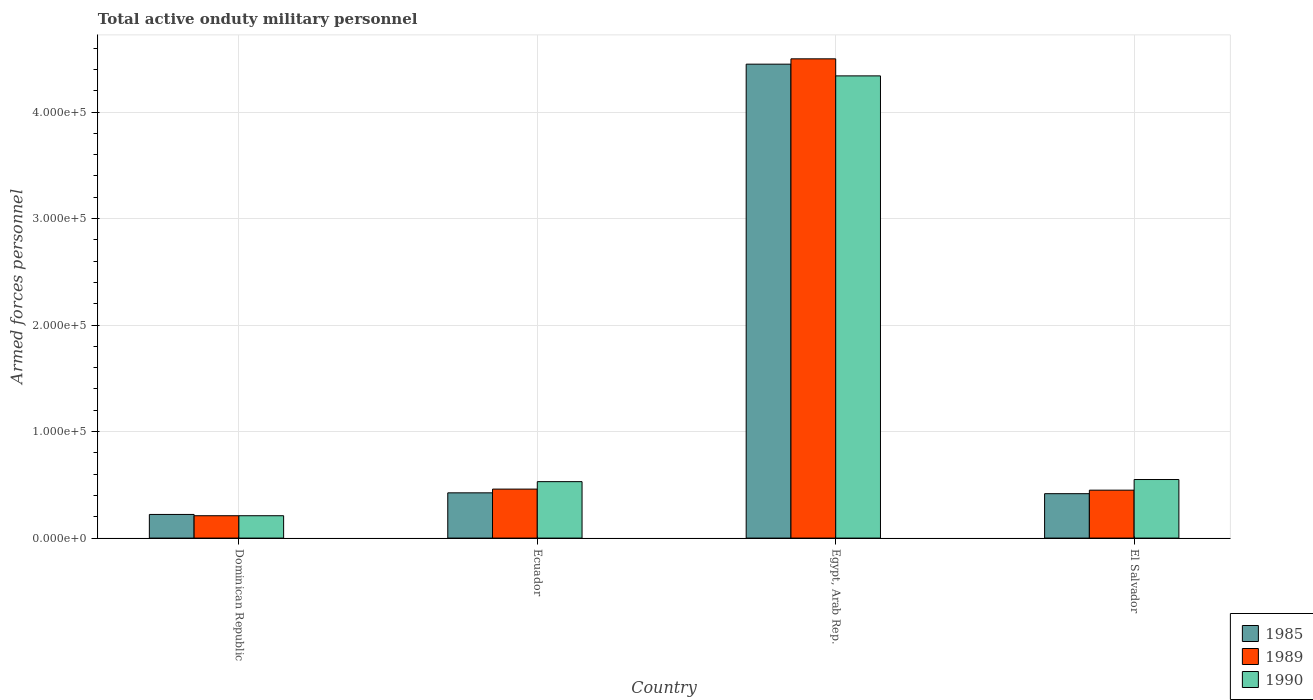How many different coloured bars are there?
Provide a succinct answer. 3. Are the number of bars per tick equal to the number of legend labels?
Provide a short and direct response. Yes. Are the number of bars on each tick of the X-axis equal?
Offer a terse response. Yes. How many bars are there on the 2nd tick from the left?
Your response must be concise. 3. How many bars are there on the 1st tick from the right?
Offer a terse response. 3. What is the label of the 1st group of bars from the left?
Your answer should be compact. Dominican Republic. What is the number of armed forces personnel in 1989 in Egypt, Arab Rep.?
Make the answer very short. 4.50e+05. Across all countries, what is the maximum number of armed forces personnel in 1990?
Give a very brief answer. 4.34e+05. Across all countries, what is the minimum number of armed forces personnel in 1990?
Your response must be concise. 2.10e+04. In which country was the number of armed forces personnel in 1985 maximum?
Offer a terse response. Egypt, Arab Rep. In which country was the number of armed forces personnel in 1989 minimum?
Offer a very short reply. Dominican Republic. What is the total number of armed forces personnel in 1989 in the graph?
Provide a succinct answer. 5.62e+05. What is the difference between the number of armed forces personnel in 1990 in Ecuador and that in Egypt, Arab Rep.?
Offer a terse response. -3.81e+05. What is the difference between the number of armed forces personnel in 1985 in Dominican Republic and the number of armed forces personnel in 1989 in Egypt, Arab Rep.?
Make the answer very short. -4.28e+05. What is the average number of armed forces personnel in 1989 per country?
Keep it short and to the point. 1.40e+05. What is the difference between the number of armed forces personnel of/in 1985 and number of armed forces personnel of/in 1989 in Dominican Republic?
Give a very brief answer. 1200. What is the ratio of the number of armed forces personnel in 1989 in Dominican Republic to that in Egypt, Arab Rep.?
Keep it short and to the point. 0.05. Is the difference between the number of armed forces personnel in 1985 in Ecuador and El Salvador greater than the difference between the number of armed forces personnel in 1989 in Ecuador and El Salvador?
Give a very brief answer. No. What is the difference between the highest and the second highest number of armed forces personnel in 1985?
Offer a terse response. 4.02e+05. What is the difference between the highest and the lowest number of armed forces personnel in 1989?
Keep it short and to the point. 4.29e+05. In how many countries, is the number of armed forces personnel in 1990 greater than the average number of armed forces personnel in 1990 taken over all countries?
Keep it short and to the point. 1. What does the 3rd bar from the left in El Salvador represents?
Provide a short and direct response. 1990. How many countries are there in the graph?
Provide a succinct answer. 4. Are the values on the major ticks of Y-axis written in scientific E-notation?
Provide a short and direct response. Yes. Where does the legend appear in the graph?
Provide a short and direct response. Bottom right. What is the title of the graph?
Provide a short and direct response. Total active onduty military personnel. What is the label or title of the Y-axis?
Your response must be concise. Armed forces personnel. What is the Armed forces personnel of 1985 in Dominican Republic?
Provide a succinct answer. 2.22e+04. What is the Armed forces personnel in 1989 in Dominican Republic?
Your answer should be compact. 2.10e+04. What is the Armed forces personnel of 1990 in Dominican Republic?
Make the answer very short. 2.10e+04. What is the Armed forces personnel of 1985 in Ecuador?
Your response must be concise. 4.25e+04. What is the Armed forces personnel of 1989 in Ecuador?
Your answer should be very brief. 4.60e+04. What is the Armed forces personnel of 1990 in Ecuador?
Keep it short and to the point. 5.30e+04. What is the Armed forces personnel in 1985 in Egypt, Arab Rep.?
Give a very brief answer. 4.45e+05. What is the Armed forces personnel of 1989 in Egypt, Arab Rep.?
Provide a succinct answer. 4.50e+05. What is the Armed forces personnel of 1990 in Egypt, Arab Rep.?
Offer a very short reply. 4.34e+05. What is the Armed forces personnel in 1985 in El Salvador?
Make the answer very short. 4.17e+04. What is the Armed forces personnel of 1989 in El Salvador?
Provide a short and direct response. 4.50e+04. What is the Armed forces personnel of 1990 in El Salvador?
Your answer should be compact. 5.50e+04. Across all countries, what is the maximum Armed forces personnel of 1985?
Make the answer very short. 4.45e+05. Across all countries, what is the maximum Armed forces personnel in 1989?
Offer a very short reply. 4.50e+05. Across all countries, what is the maximum Armed forces personnel of 1990?
Make the answer very short. 4.34e+05. Across all countries, what is the minimum Armed forces personnel of 1985?
Provide a short and direct response. 2.22e+04. Across all countries, what is the minimum Armed forces personnel in 1989?
Provide a succinct answer. 2.10e+04. Across all countries, what is the minimum Armed forces personnel in 1990?
Provide a short and direct response. 2.10e+04. What is the total Armed forces personnel of 1985 in the graph?
Ensure brevity in your answer.  5.51e+05. What is the total Armed forces personnel of 1989 in the graph?
Offer a very short reply. 5.62e+05. What is the total Armed forces personnel of 1990 in the graph?
Offer a very short reply. 5.63e+05. What is the difference between the Armed forces personnel in 1985 in Dominican Republic and that in Ecuador?
Provide a succinct answer. -2.03e+04. What is the difference between the Armed forces personnel of 1989 in Dominican Republic and that in Ecuador?
Offer a terse response. -2.50e+04. What is the difference between the Armed forces personnel of 1990 in Dominican Republic and that in Ecuador?
Your answer should be compact. -3.20e+04. What is the difference between the Armed forces personnel of 1985 in Dominican Republic and that in Egypt, Arab Rep.?
Give a very brief answer. -4.23e+05. What is the difference between the Armed forces personnel in 1989 in Dominican Republic and that in Egypt, Arab Rep.?
Ensure brevity in your answer.  -4.29e+05. What is the difference between the Armed forces personnel in 1990 in Dominican Republic and that in Egypt, Arab Rep.?
Give a very brief answer. -4.13e+05. What is the difference between the Armed forces personnel of 1985 in Dominican Republic and that in El Salvador?
Offer a very short reply. -1.95e+04. What is the difference between the Armed forces personnel of 1989 in Dominican Republic and that in El Salvador?
Your response must be concise. -2.40e+04. What is the difference between the Armed forces personnel in 1990 in Dominican Republic and that in El Salvador?
Provide a short and direct response. -3.40e+04. What is the difference between the Armed forces personnel of 1985 in Ecuador and that in Egypt, Arab Rep.?
Your answer should be very brief. -4.02e+05. What is the difference between the Armed forces personnel of 1989 in Ecuador and that in Egypt, Arab Rep.?
Provide a short and direct response. -4.04e+05. What is the difference between the Armed forces personnel in 1990 in Ecuador and that in Egypt, Arab Rep.?
Offer a very short reply. -3.81e+05. What is the difference between the Armed forces personnel in 1985 in Ecuador and that in El Salvador?
Offer a very short reply. 800. What is the difference between the Armed forces personnel in 1990 in Ecuador and that in El Salvador?
Your answer should be compact. -2000. What is the difference between the Armed forces personnel in 1985 in Egypt, Arab Rep. and that in El Salvador?
Provide a succinct answer. 4.03e+05. What is the difference between the Armed forces personnel of 1989 in Egypt, Arab Rep. and that in El Salvador?
Keep it short and to the point. 4.05e+05. What is the difference between the Armed forces personnel in 1990 in Egypt, Arab Rep. and that in El Salvador?
Ensure brevity in your answer.  3.79e+05. What is the difference between the Armed forces personnel of 1985 in Dominican Republic and the Armed forces personnel of 1989 in Ecuador?
Give a very brief answer. -2.38e+04. What is the difference between the Armed forces personnel in 1985 in Dominican Republic and the Armed forces personnel in 1990 in Ecuador?
Your response must be concise. -3.08e+04. What is the difference between the Armed forces personnel of 1989 in Dominican Republic and the Armed forces personnel of 1990 in Ecuador?
Provide a succinct answer. -3.20e+04. What is the difference between the Armed forces personnel of 1985 in Dominican Republic and the Armed forces personnel of 1989 in Egypt, Arab Rep.?
Give a very brief answer. -4.28e+05. What is the difference between the Armed forces personnel of 1985 in Dominican Republic and the Armed forces personnel of 1990 in Egypt, Arab Rep.?
Offer a very short reply. -4.12e+05. What is the difference between the Armed forces personnel in 1989 in Dominican Republic and the Armed forces personnel in 1990 in Egypt, Arab Rep.?
Your answer should be very brief. -4.13e+05. What is the difference between the Armed forces personnel of 1985 in Dominican Republic and the Armed forces personnel of 1989 in El Salvador?
Provide a succinct answer. -2.28e+04. What is the difference between the Armed forces personnel in 1985 in Dominican Republic and the Armed forces personnel in 1990 in El Salvador?
Provide a succinct answer. -3.28e+04. What is the difference between the Armed forces personnel in 1989 in Dominican Republic and the Armed forces personnel in 1990 in El Salvador?
Give a very brief answer. -3.40e+04. What is the difference between the Armed forces personnel of 1985 in Ecuador and the Armed forces personnel of 1989 in Egypt, Arab Rep.?
Your answer should be compact. -4.08e+05. What is the difference between the Armed forces personnel in 1985 in Ecuador and the Armed forces personnel in 1990 in Egypt, Arab Rep.?
Provide a short and direct response. -3.92e+05. What is the difference between the Armed forces personnel in 1989 in Ecuador and the Armed forces personnel in 1990 in Egypt, Arab Rep.?
Your answer should be very brief. -3.88e+05. What is the difference between the Armed forces personnel of 1985 in Ecuador and the Armed forces personnel of 1989 in El Salvador?
Provide a short and direct response. -2500. What is the difference between the Armed forces personnel in 1985 in Ecuador and the Armed forces personnel in 1990 in El Salvador?
Provide a short and direct response. -1.25e+04. What is the difference between the Armed forces personnel of 1989 in Ecuador and the Armed forces personnel of 1990 in El Salvador?
Give a very brief answer. -9000. What is the difference between the Armed forces personnel of 1989 in Egypt, Arab Rep. and the Armed forces personnel of 1990 in El Salvador?
Keep it short and to the point. 3.95e+05. What is the average Armed forces personnel in 1985 per country?
Your answer should be very brief. 1.38e+05. What is the average Armed forces personnel in 1989 per country?
Provide a short and direct response. 1.40e+05. What is the average Armed forces personnel in 1990 per country?
Your answer should be compact. 1.41e+05. What is the difference between the Armed forces personnel in 1985 and Armed forces personnel in 1989 in Dominican Republic?
Make the answer very short. 1200. What is the difference between the Armed forces personnel of 1985 and Armed forces personnel of 1990 in Dominican Republic?
Your answer should be compact. 1200. What is the difference between the Armed forces personnel in 1989 and Armed forces personnel in 1990 in Dominican Republic?
Your response must be concise. 0. What is the difference between the Armed forces personnel of 1985 and Armed forces personnel of 1989 in Ecuador?
Keep it short and to the point. -3500. What is the difference between the Armed forces personnel in 1985 and Armed forces personnel in 1990 in Ecuador?
Your answer should be very brief. -1.05e+04. What is the difference between the Armed forces personnel in 1989 and Armed forces personnel in 1990 in Ecuador?
Your response must be concise. -7000. What is the difference between the Armed forces personnel in 1985 and Armed forces personnel in 1989 in Egypt, Arab Rep.?
Offer a terse response. -5000. What is the difference between the Armed forces personnel of 1985 and Armed forces personnel of 1990 in Egypt, Arab Rep.?
Your answer should be compact. 1.10e+04. What is the difference between the Armed forces personnel in 1989 and Armed forces personnel in 1990 in Egypt, Arab Rep.?
Give a very brief answer. 1.60e+04. What is the difference between the Armed forces personnel in 1985 and Armed forces personnel in 1989 in El Salvador?
Keep it short and to the point. -3300. What is the difference between the Armed forces personnel in 1985 and Armed forces personnel in 1990 in El Salvador?
Provide a short and direct response. -1.33e+04. What is the ratio of the Armed forces personnel in 1985 in Dominican Republic to that in Ecuador?
Offer a very short reply. 0.52. What is the ratio of the Armed forces personnel of 1989 in Dominican Republic to that in Ecuador?
Ensure brevity in your answer.  0.46. What is the ratio of the Armed forces personnel of 1990 in Dominican Republic to that in Ecuador?
Provide a short and direct response. 0.4. What is the ratio of the Armed forces personnel of 1985 in Dominican Republic to that in Egypt, Arab Rep.?
Your answer should be compact. 0.05. What is the ratio of the Armed forces personnel of 1989 in Dominican Republic to that in Egypt, Arab Rep.?
Ensure brevity in your answer.  0.05. What is the ratio of the Armed forces personnel in 1990 in Dominican Republic to that in Egypt, Arab Rep.?
Provide a short and direct response. 0.05. What is the ratio of the Armed forces personnel in 1985 in Dominican Republic to that in El Salvador?
Offer a terse response. 0.53. What is the ratio of the Armed forces personnel in 1989 in Dominican Republic to that in El Salvador?
Your answer should be compact. 0.47. What is the ratio of the Armed forces personnel in 1990 in Dominican Republic to that in El Salvador?
Ensure brevity in your answer.  0.38. What is the ratio of the Armed forces personnel of 1985 in Ecuador to that in Egypt, Arab Rep.?
Ensure brevity in your answer.  0.1. What is the ratio of the Armed forces personnel of 1989 in Ecuador to that in Egypt, Arab Rep.?
Make the answer very short. 0.1. What is the ratio of the Armed forces personnel in 1990 in Ecuador to that in Egypt, Arab Rep.?
Give a very brief answer. 0.12. What is the ratio of the Armed forces personnel of 1985 in Ecuador to that in El Salvador?
Ensure brevity in your answer.  1.02. What is the ratio of the Armed forces personnel of 1989 in Ecuador to that in El Salvador?
Your response must be concise. 1.02. What is the ratio of the Armed forces personnel in 1990 in Ecuador to that in El Salvador?
Ensure brevity in your answer.  0.96. What is the ratio of the Armed forces personnel in 1985 in Egypt, Arab Rep. to that in El Salvador?
Keep it short and to the point. 10.67. What is the ratio of the Armed forces personnel of 1989 in Egypt, Arab Rep. to that in El Salvador?
Your response must be concise. 10. What is the ratio of the Armed forces personnel of 1990 in Egypt, Arab Rep. to that in El Salvador?
Your answer should be compact. 7.89. What is the difference between the highest and the second highest Armed forces personnel in 1985?
Provide a short and direct response. 4.02e+05. What is the difference between the highest and the second highest Armed forces personnel in 1989?
Make the answer very short. 4.04e+05. What is the difference between the highest and the second highest Armed forces personnel of 1990?
Keep it short and to the point. 3.79e+05. What is the difference between the highest and the lowest Armed forces personnel of 1985?
Give a very brief answer. 4.23e+05. What is the difference between the highest and the lowest Armed forces personnel of 1989?
Offer a terse response. 4.29e+05. What is the difference between the highest and the lowest Armed forces personnel in 1990?
Your answer should be compact. 4.13e+05. 